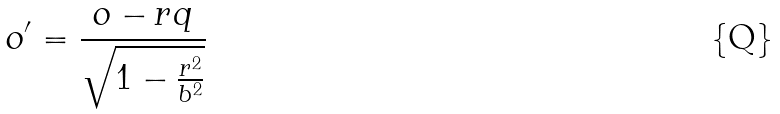Convert formula to latex. <formula><loc_0><loc_0><loc_500><loc_500>o ^ { \prime } = \frac { o - r q } { \sqrt { 1 - \frac { r ^ { 2 } } { b ^ { 2 } } } }</formula> 